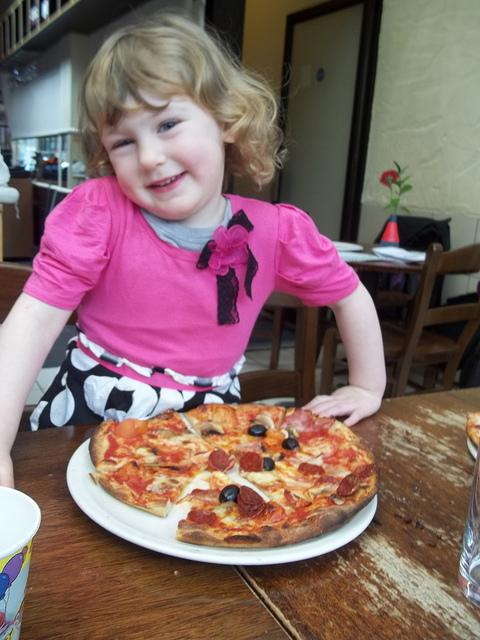What fruit might this person eat first?

Choices:
A) kiwi
B) olives
C) acai berries
D) ugli olives 